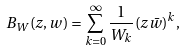Convert formula to latex. <formula><loc_0><loc_0><loc_500><loc_500>B _ { W } ( z , w ) = \sum _ { k = 0 } ^ { \infty } \frac { 1 } { W _ { k } } ( z \bar { w } ) ^ { k } ,</formula> 